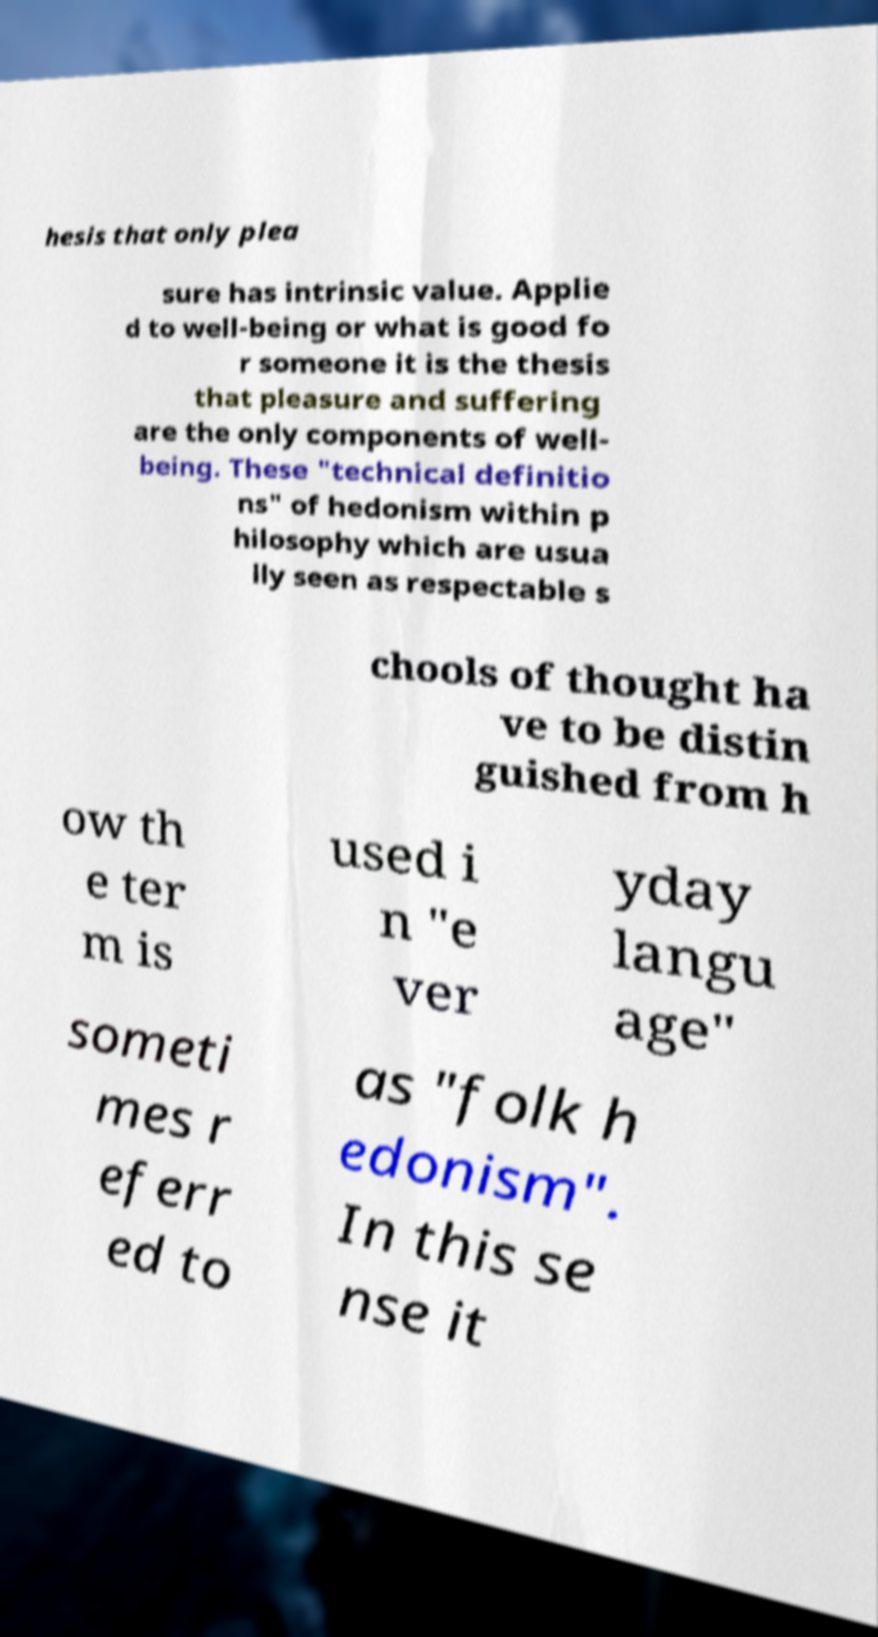Can you accurately transcribe the text from the provided image for me? hesis that only plea sure has intrinsic value. Applie d to well-being or what is good fo r someone it is the thesis that pleasure and suffering are the only components of well- being. These "technical definitio ns" of hedonism within p hilosophy which are usua lly seen as respectable s chools of thought ha ve to be distin guished from h ow th e ter m is used i n "e ver yday langu age" someti mes r eferr ed to as "folk h edonism". In this se nse it 